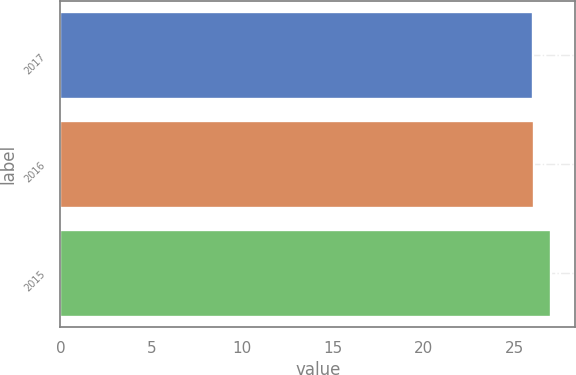Convert chart. <chart><loc_0><loc_0><loc_500><loc_500><bar_chart><fcel>2017<fcel>2016<fcel>2015<nl><fcel>26<fcel>26.1<fcel>27<nl></chart> 